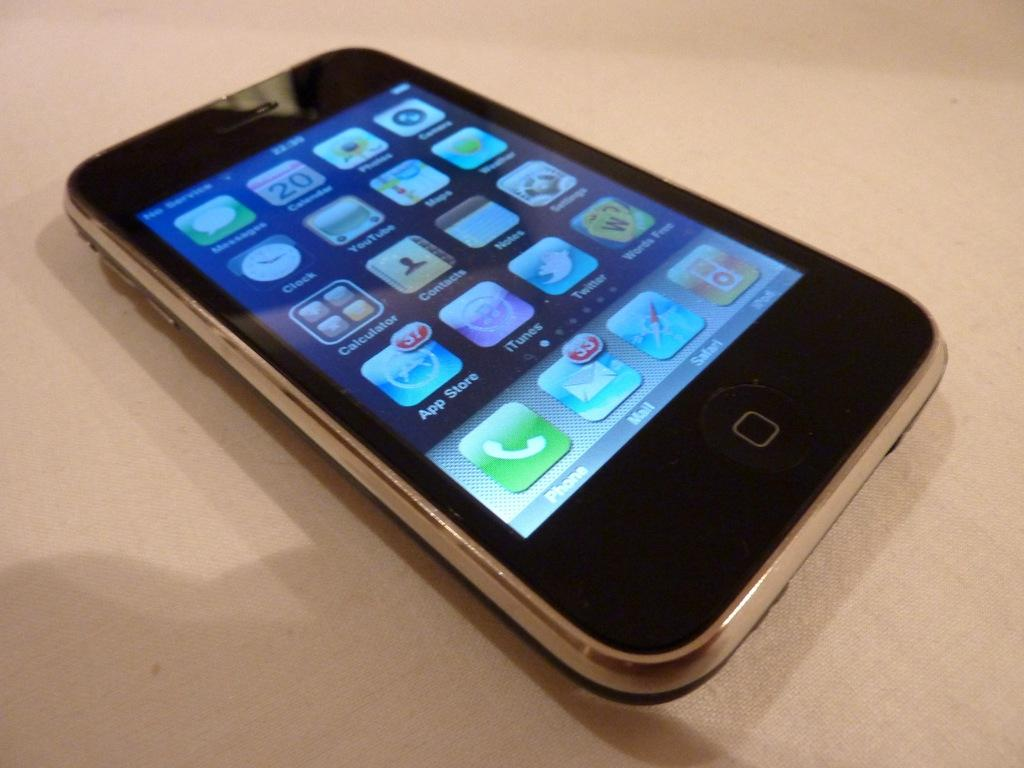<image>
Summarize the visual content of the image. A phone screen is lit up with the email app showing thirty three messages waiting. 